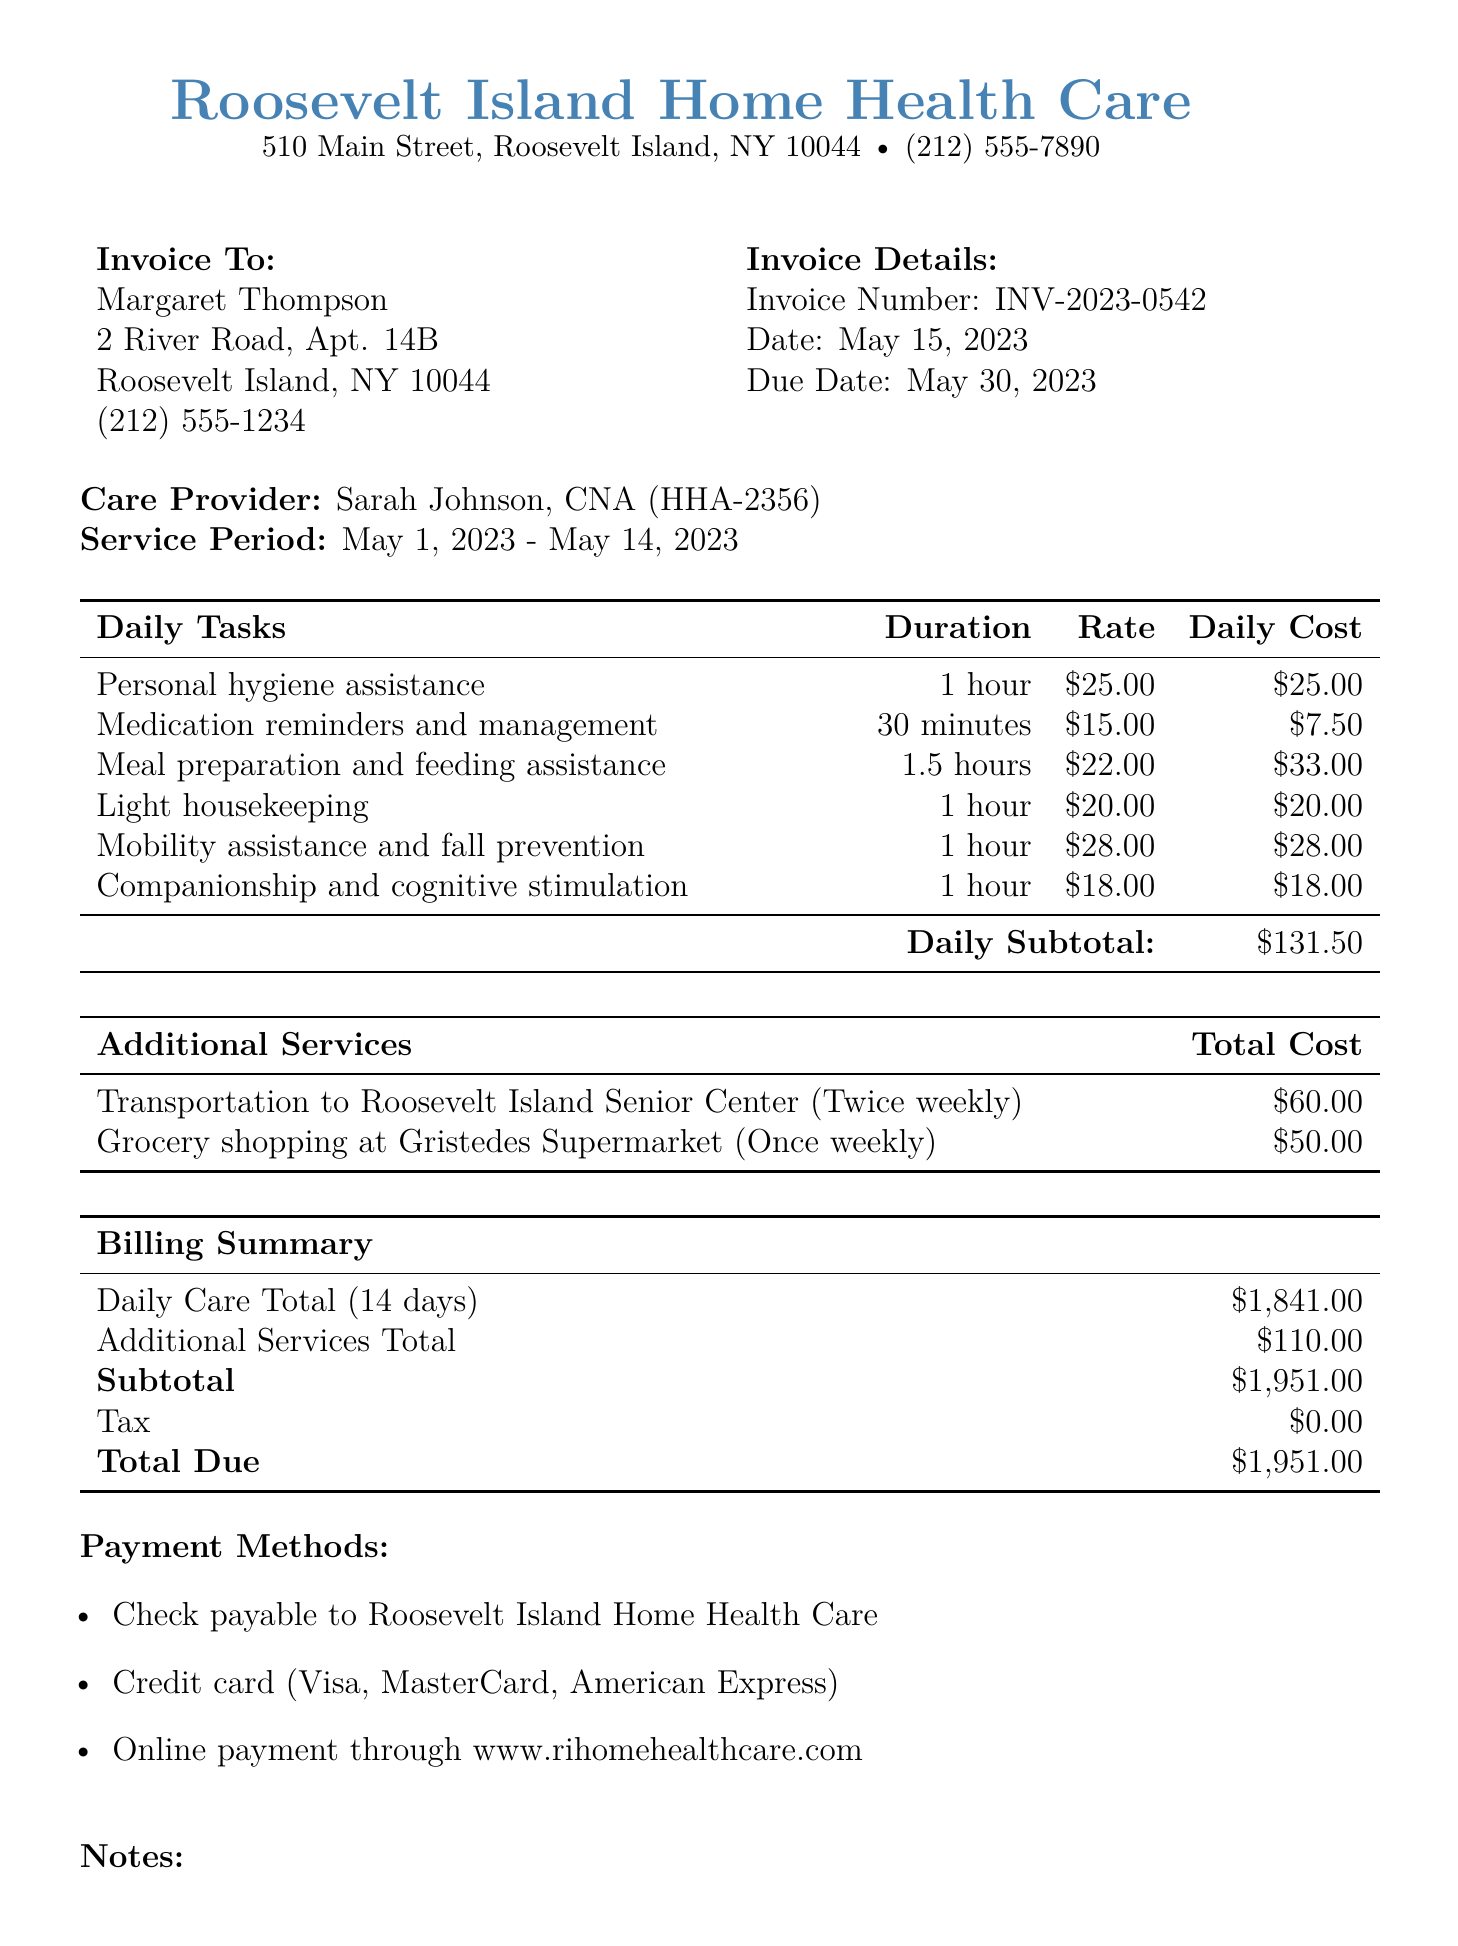What is the total due amount? The total due amount is mentioned in the billing summary of the document, which includes the total cost for services rendered.
Answer: $1,951.00 Who is the care provider? The care provider's name is stated in the document, along with their title and employee ID.
Answer: Sarah Johnson, CNA What is the invoice number? The invoice number is clearly indicated in the invoice details section of the document.
Answer: INV-2023-0542 What is the frequency of grocery shopping service? The frequency of the grocery shopping service appears in the additional services section, specifying how often the service is provided.
Answer: Once weekly How many days of service were provided? The number of service days can be found in the billing summary and indicates the total duration of care received.
Answer: 14 What is the daily subtotal for daily care tasks? The daily subtotal is calculated by summing the daily costs of individual daily care tasks listed in the document.
Answer: $131.50 What is the start date of the service period? The start date of the service period is specified in the service period section of the document.
Answer: May 1, 2023 How many times per week is transportation provided? The document specifies the transportation service's frequency, indicating how often it is provided to the client.
Answer: Twice weekly 